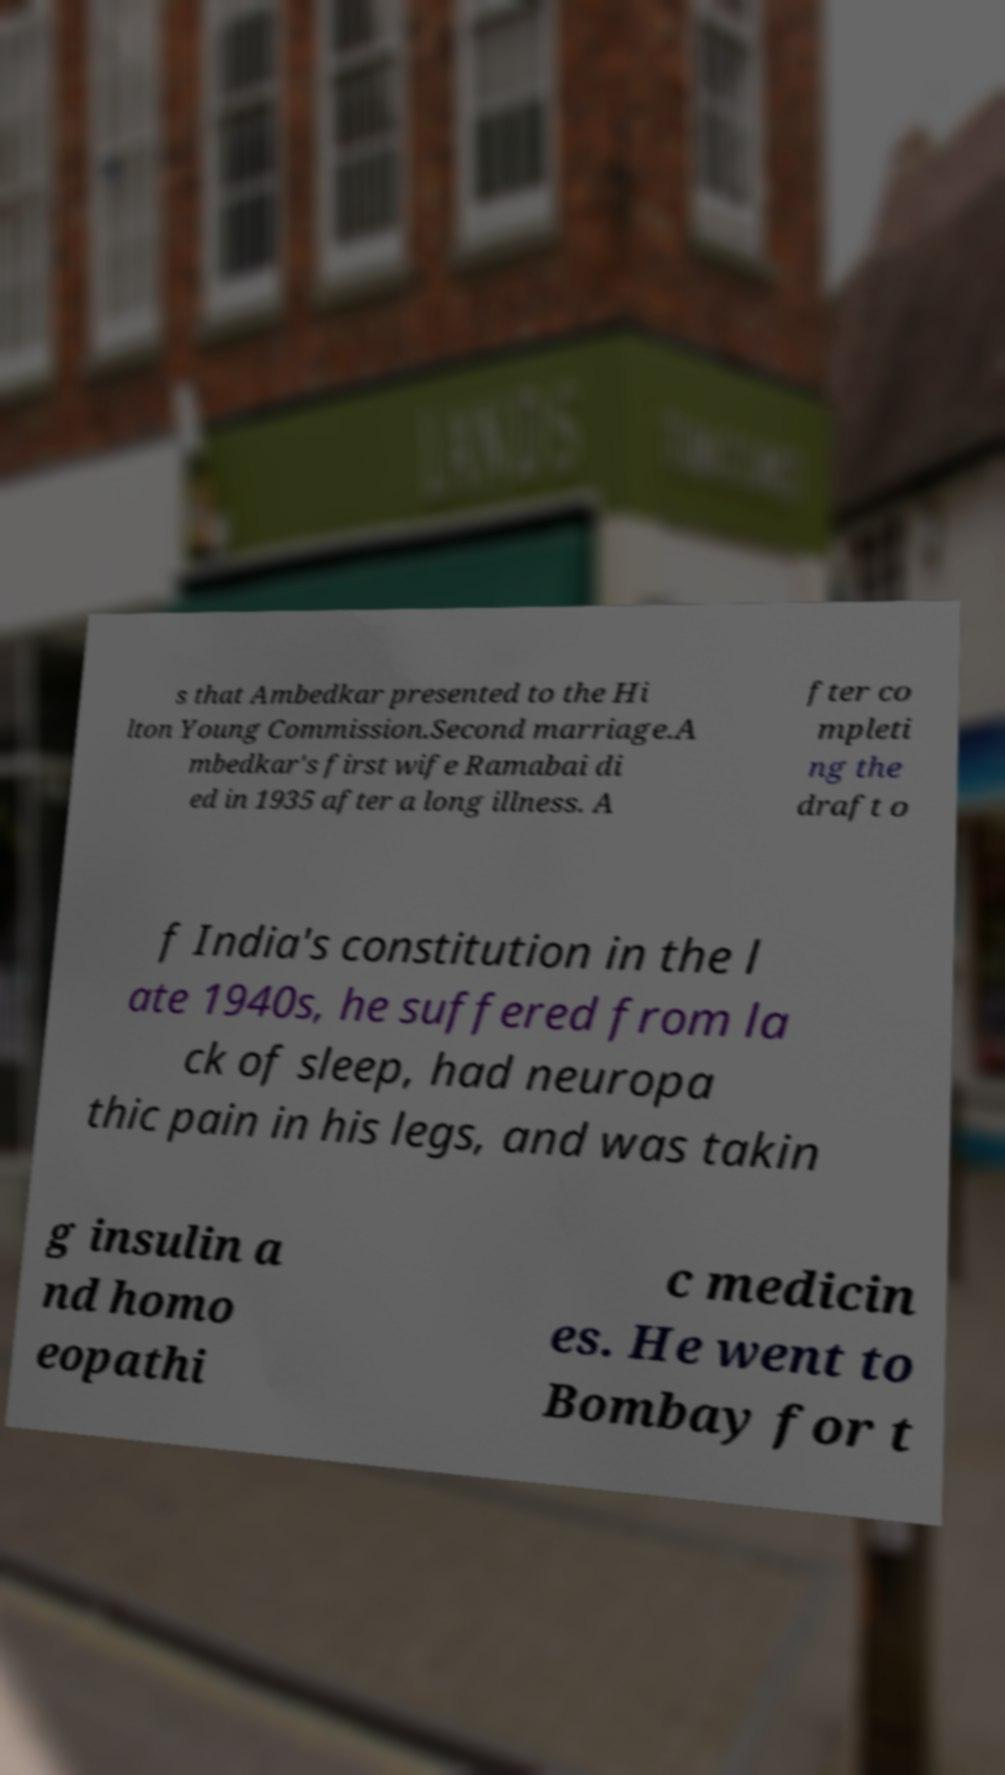Can you accurately transcribe the text from the provided image for me? s that Ambedkar presented to the Hi lton Young Commission.Second marriage.A mbedkar's first wife Ramabai di ed in 1935 after a long illness. A fter co mpleti ng the draft o f India's constitution in the l ate 1940s, he suffered from la ck of sleep, had neuropa thic pain in his legs, and was takin g insulin a nd homo eopathi c medicin es. He went to Bombay for t 